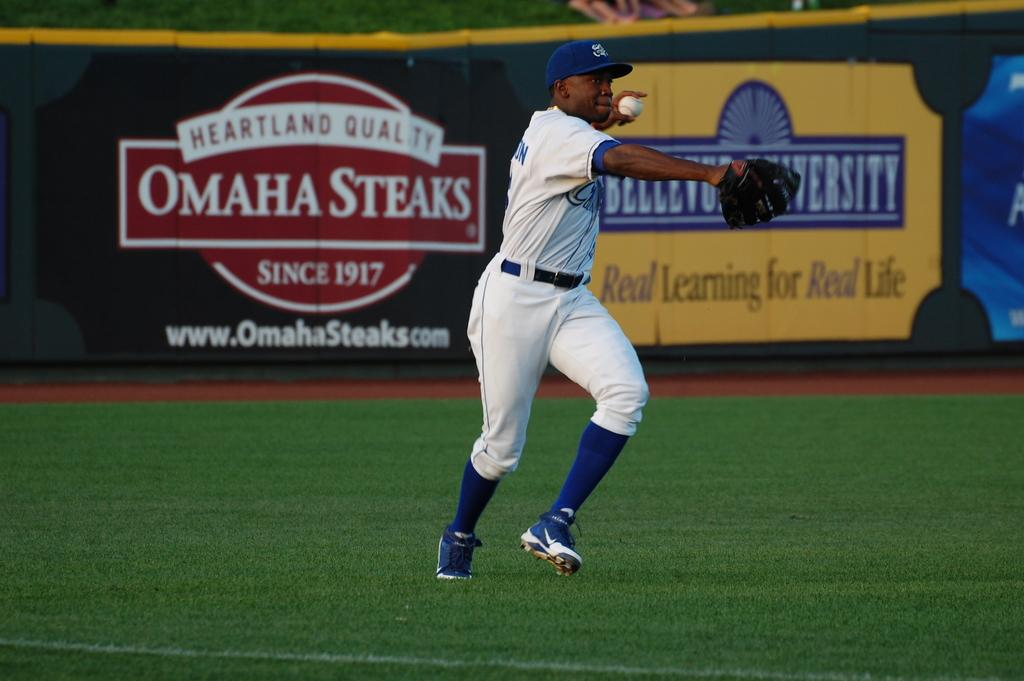<image>
Provide a brief description of the given image. A baseball player in a field with bilboards behind him with ads for Omaha Steaks. 